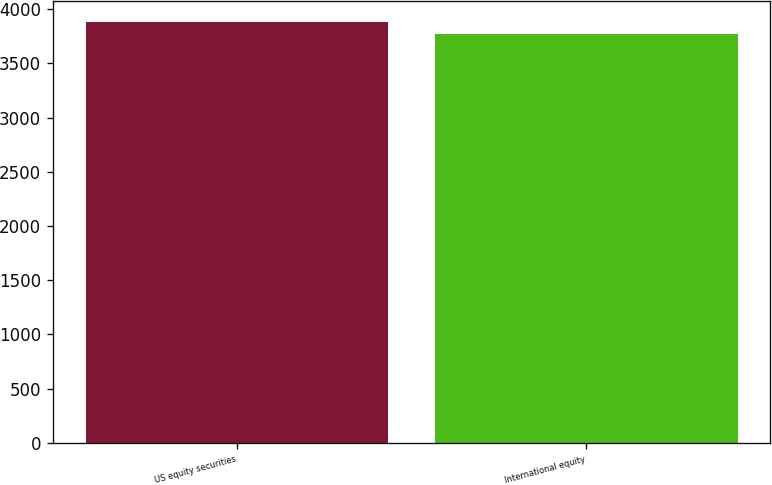<chart> <loc_0><loc_0><loc_500><loc_500><bar_chart><fcel>US equity securities<fcel>International equity<nl><fcel>3878<fcel>3776<nl></chart> 